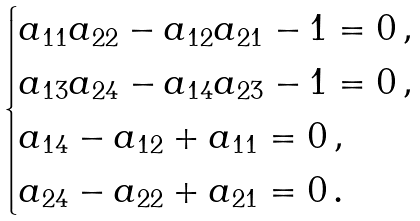Convert formula to latex. <formula><loc_0><loc_0><loc_500><loc_500>\begin{cases} a _ { 1 1 } a _ { 2 2 } - a _ { 1 2 } a _ { 2 1 } - 1 = 0 \, , \\ a _ { 1 3 } a _ { 2 4 } - a _ { 1 4 } a _ { 2 3 } - 1 = 0 \, , \\ a _ { 1 4 } - a _ { 1 2 } + a _ { 1 1 } = 0 \, , \\ a _ { 2 4 } - a _ { 2 2 } + a _ { 2 1 } = 0 \, . \end{cases}</formula> 